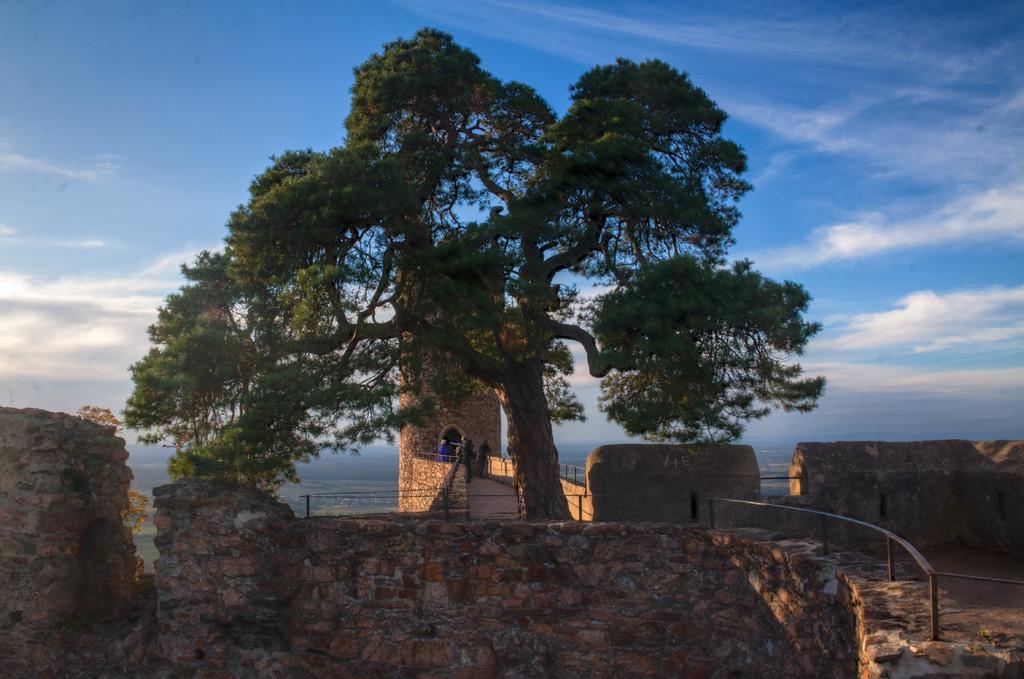Describe this image in one or two sentences. In this picture we can see a few people in the fort. There is a fence on the right side. We can see a tree. Sky is blue in color and cloudy. 